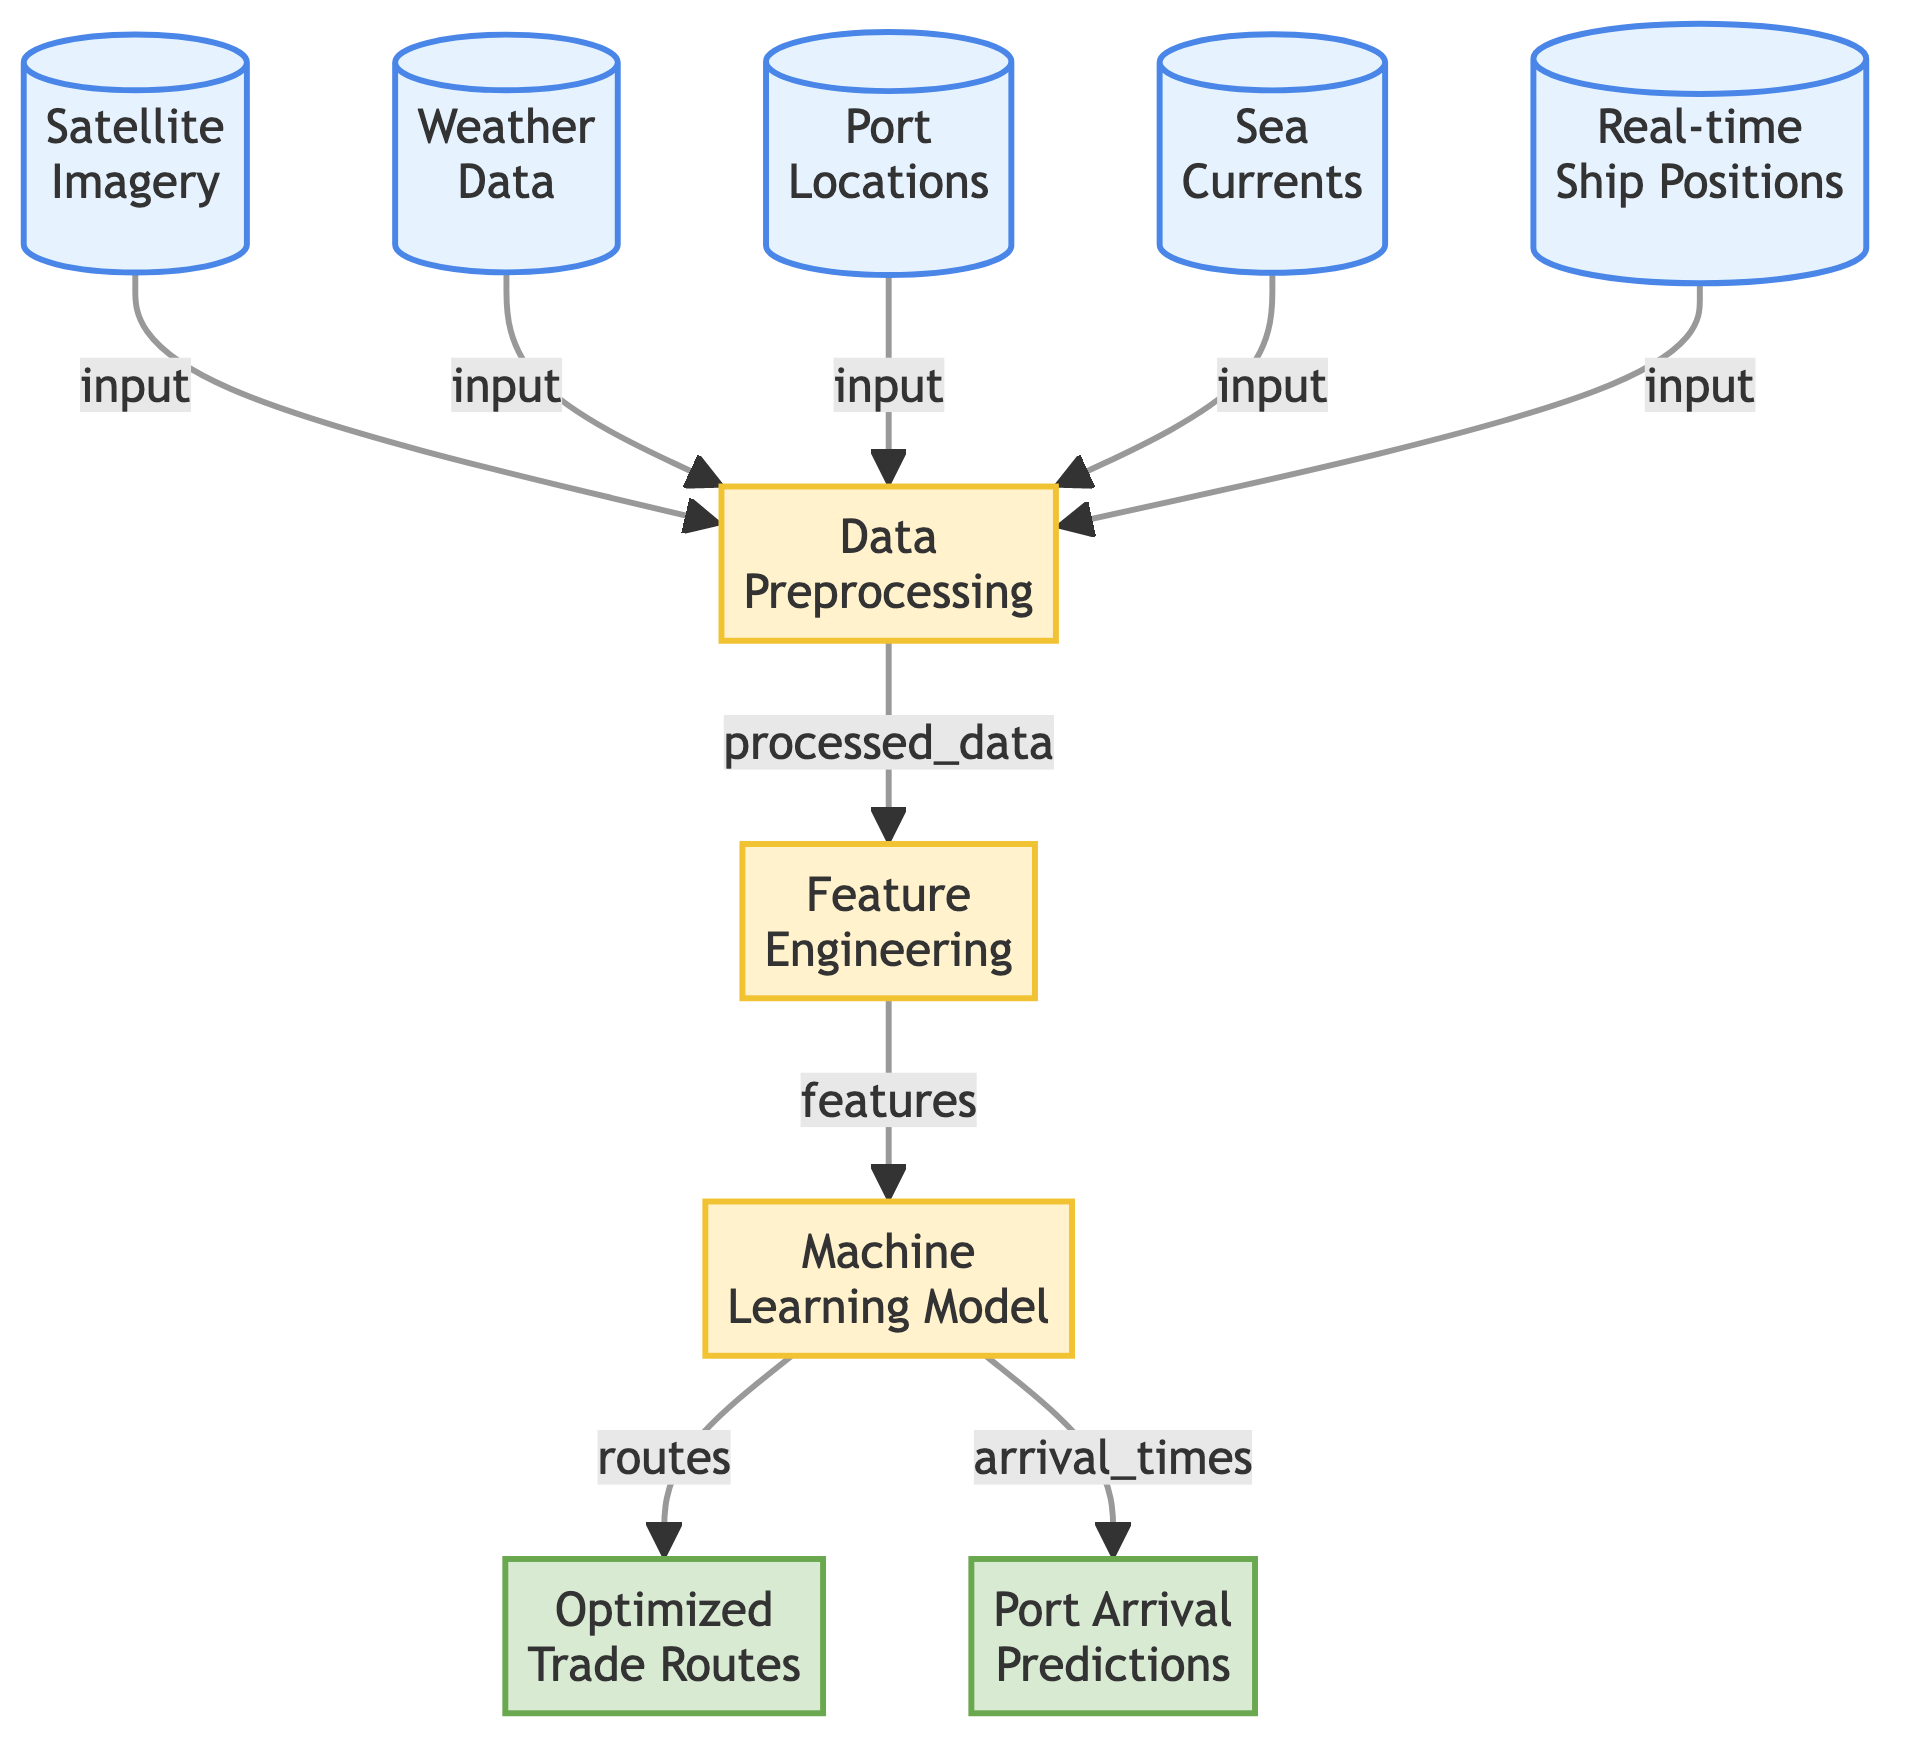What are the data sources used in this diagram? The diagram lists five data sources: Satellite Imagery, Weather Data, Port Locations, Sea Currents, and Real-time Ship Positions. These are indicated by the nodes connecting to the Data Preprocessing node.
Answer: Five What is the first process shown in the diagram? The diagram indicates that Data Preprocessing is the first process in the flow, listed as the first process node after the input data sources.
Answer: Data Preprocessing How many output nodes are there in the diagram? The diagram contains two output nodes: Optimized Trade Routes and Port Arrival Predictions. These can be counted from the last section of the flowchart.
Answer: Two Which data source is directly connected to the Data Preprocessing node? All five data sources (Satellite Imagery, Weather Data, Port Locations, Sea Currents, Real-time Ship Positions) are directly connected to the Data Preprocessing node, indicating they all feed into this process.
Answer: All five What type of data is used for feature engineering in the diagram? The feature engineering process receives processed data which is derived from all the data sources combined in the Data Preprocessing node. This processed data contains features extracted from the different inputs.
Answer: Processed Data What outputs are generated by the Machine Learning Model? The Machine Learning Model generates two types of outputs, which are Optimized Trade Routes and Port Arrival Predictions. These are indicated as the two output nodes connected to the Machine Learning Model node.
Answer: Optimized Trade Routes and Port Arrival Predictions Which node serves as input to the Machine Learning Model? The Feature Engineering node processes the data and outputs it as features that are then used as input for the Machine Learning Model, connecting them in the flow.
Answer: Feature Engineering How does the flow of data begin in this diagram? The flow of data begins with the five data source nodes, all of which point to the Data Preprocessing node as their next step in the process. This establishes the starting point of the diagram's flow.
Answer: Five data sources What type of model is used in this diagram? The diagram employs a Machine Learning Model that is specifically designated as the process for analyzing the features extracted from the data to optimize trade routes.
Answer: Machine Learning Model 